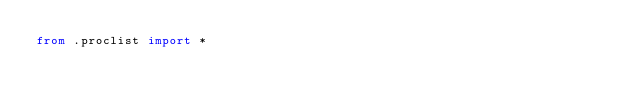Convert code to text. <code><loc_0><loc_0><loc_500><loc_500><_Python_>from .proclist import *</code> 